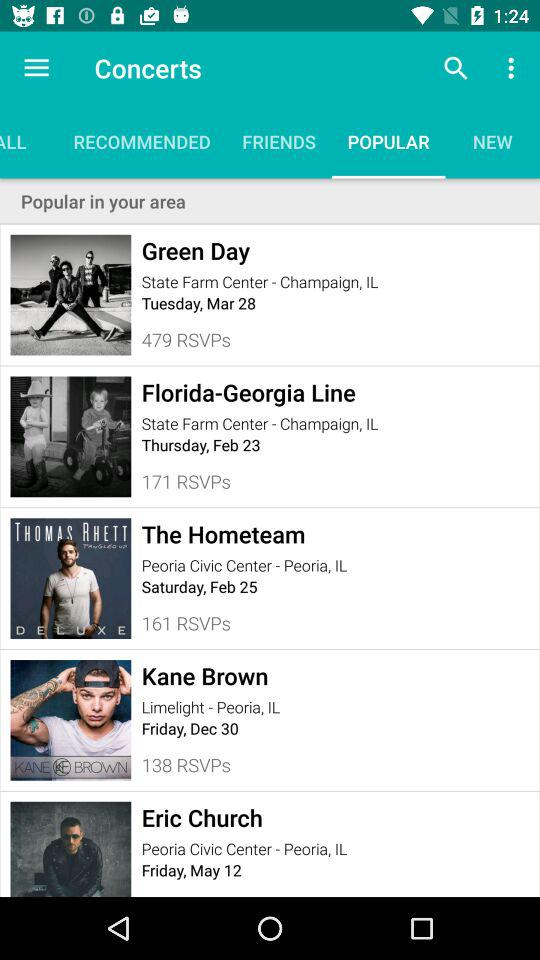What is the date of the "Green Day" concert? The date of the "Green Day" concert is Tuesday, March 28. 